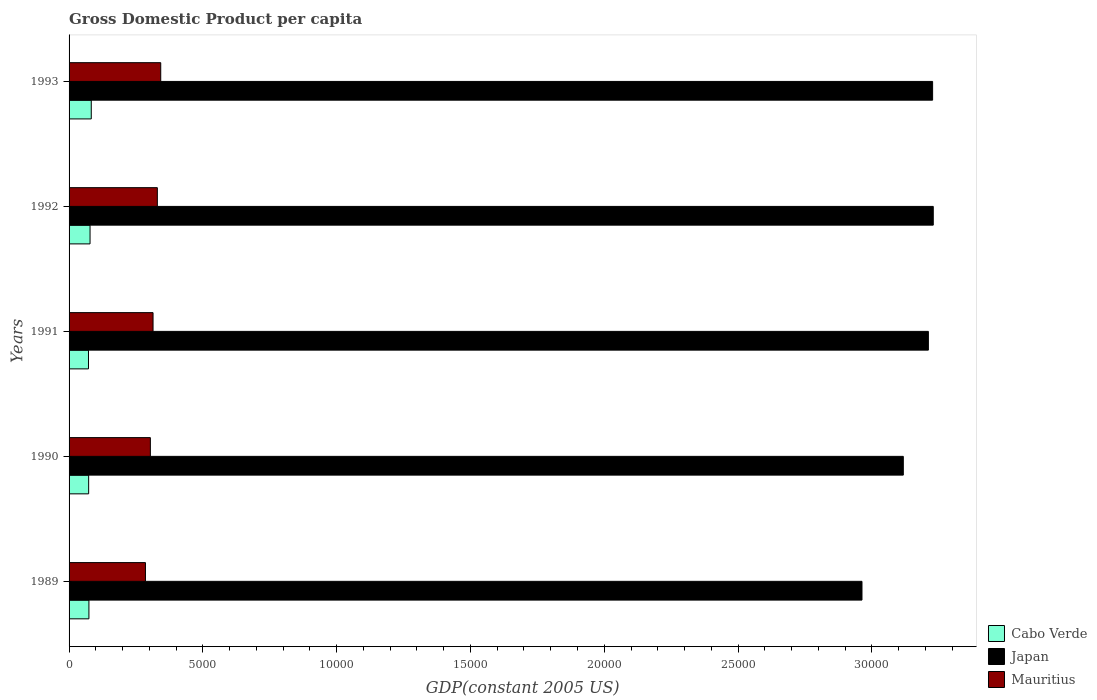How many different coloured bars are there?
Give a very brief answer. 3. How many groups of bars are there?
Offer a terse response. 5. Are the number of bars on each tick of the Y-axis equal?
Provide a succinct answer. Yes. What is the label of the 4th group of bars from the top?
Make the answer very short. 1990. What is the GDP per capita in Cabo Verde in 1990?
Your answer should be compact. 732.17. Across all years, what is the maximum GDP per capita in Japan?
Make the answer very short. 3.23e+04. Across all years, what is the minimum GDP per capita in Japan?
Offer a terse response. 2.96e+04. In which year was the GDP per capita in Cabo Verde maximum?
Provide a succinct answer. 1993. In which year was the GDP per capita in Cabo Verde minimum?
Your answer should be compact. 1991. What is the total GDP per capita in Mauritius in the graph?
Offer a terse response. 1.58e+04. What is the difference between the GDP per capita in Japan in 1989 and that in 1993?
Your answer should be very brief. -2639.3. What is the difference between the GDP per capita in Japan in 1991 and the GDP per capita in Cabo Verde in 1989?
Your answer should be very brief. 3.14e+04. What is the average GDP per capita in Cabo Verde per year?
Your answer should be compact. 762.56. In the year 1993, what is the difference between the GDP per capita in Mauritius and GDP per capita in Japan?
Keep it short and to the point. -2.88e+04. In how many years, is the GDP per capita in Cabo Verde greater than 21000 US$?
Your answer should be very brief. 0. What is the ratio of the GDP per capita in Japan in 1990 to that in 1991?
Give a very brief answer. 0.97. Is the difference between the GDP per capita in Mauritius in 1990 and 1991 greater than the difference between the GDP per capita in Japan in 1990 and 1991?
Provide a short and direct response. Yes. What is the difference between the highest and the second highest GDP per capita in Japan?
Provide a short and direct response. 24.5. What is the difference between the highest and the lowest GDP per capita in Cabo Verde?
Make the answer very short. 104.06. In how many years, is the GDP per capita in Mauritius greater than the average GDP per capita in Mauritius taken over all years?
Ensure brevity in your answer.  2. What does the 1st bar from the top in 1990 represents?
Offer a very short reply. Mauritius. What does the 3rd bar from the bottom in 1990 represents?
Keep it short and to the point. Mauritius. How many bars are there?
Keep it short and to the point. 15. How many years are there in the graph?
Your response must be concise. 5. What is the difference between two consecutive major ticks on the X-axis?
Your answer should be compact. 5000. Does the graph contain any zero values?
Give a very brief answer. No. Where does the legend appear in the graph?
Offer a very short reply. Bottom right. How are the legend labels stacked?
Keep it short and to the point. Vertical. What is the title of the graph?
Your answer should be very brief. Gross Domestic Product per capita. Does "Belgium" appear as one of the legend labels in the graph?
Your answer should be very brief. No. What is the label or title of the X-axis?
Your answer should be very brief. GDP(constant 2005 US). What is the GDP(constant 2005 US) in Cabo Verde in 1989?
Provide a succinct answer. 741.88. What is the GDP(constant 2005 US) of Japan in 1989?
Your answer should be compact. 2.96e+04. What is the GDP(constant 2005 US) of Mauritius in 1989?
Your response must be concise. 2854.06. What is the GDP(constant 2005 US) in Cabo Verde in 1990?
Provide a succinct answer. 732.17. What is the GDP(constant 2005 US) in Japan in 1990?
Your response must be concise. 3.12e+04. What is the GDP(constant 2005 US) of Mauritius in 1990?
Provide a succinct answer. 3037.46. What is the GDP(constant 2005 US) in Cabo Verde in 1991?
Make the answer very short. 725.3. What is the GDP(constant 2005 US) in Japan in 1991?
Provide a succinct answer. 3.21e+04. What is the GDP(constant 2005 US) of Mauritius in 1991?
Keep it short and to the point. 3138.13. What is the GDP(constant 2005 US) of Cabo Verde in 1992?
Offer a terse response. 784.1. What is the GDP(constant 2005 US) in Japan in 1992?
Offer a very short reply. 3.23e+04. What is the GDP(constant 2005 US) of Mauritius in 1992?
Your answer should be compact. 3298.81. What is the GDP(constant 2005 US) in Cabo Verde in 1993?
Keep it short and to the point. 829.36. What is the GDP(constant 2005 US) of Japan in 1993?
Your answer should be very brief. 3.23e+04. What is the GDP(constant 2005 US) in Mauritius in 1993?
Give a very brief answer. 3425.61. Across all years, what is the maximum GDP(constant 2005 US) of Cabo Verde?
Your answer should be compact. 829.36. Across all years, what is the maximum GDP(constant 2005 US) of Japan?
Provide a succinct answer. 3.23e+04. Across all years, what is the maximum GDP(constant 2005 US) of Mauritius?
Your answer should be compact. 3425.61. Across all years, what is the minimum GDP(constant 2005 US) in Cabo Verde?
Provide a succinct answer. 725.3. Across all years, what is the minimum GDP(constant 2005 US) in Japan?
Provide a short and direct response. 2.96e+04. Across all years, what is the minimum GDP(constant 2005 US) in Mauritius?
Provide a succinct answer. 2854.06. What is the total GDP(constant 2005 US) in Cabo Verde in the graph?
Make the answer very short. 3812.82. What is the total GDP(constant 2005 US) of Japan in the graph?
Ensure brevity in your answer.  1.57e+05. What is the total GDP(constant 2005 US) in Mauritius in the graph?
Give a very brief answer. 1.58e+04. What is the difference between the GDP(constant 2005 US) in Cabo Verde in 1989 and that in 1990?
Ensure brevity in your answer.  9.71. What is the difference between the GDP(constant 2005 US) in Japan in 1989 and that in 1990?
Your answer should be very brief. -1544.52. What is the difference between the GDP(constant 2005 US) of Mauritius in 1989 and that in 1990?
Give a very brief answer. -183.4. What is the difference between the GDP(constant 2005 US) of Cabo Verde in 1989 and that in 1991?
Make the answer very short. 16.58. What is the difference between the GDP(constant 2005 US) in Japan in 1989 and that in 1991?
Your answer should be very brief. -2481.07. What is the difference between the GDP(constant 2005 US) of Mauritius in 1989 and that in 1991?
Your answer should be very brief. -284.07. What is the difference between the GDP(constant 2005 US) in Cabo Verde in 1989 and that in 1992?
Your response must be concise. -42.22. What is the difference between the GDP(constant 2005 US) in Japan in 1989 and that in 1992?
Provide a succinct answer. -2663.81. What is the difference between the GDP(constant 2005 US) of Mauritius in 1989 and that in 1992?
Offer a very short reply. -444.75. What is the difference between the GDP(constant 2005 US) in Cabo Verde in 1989 and that in 1993?
Your answer should be very brief. -87.48. What is the difference between the GDP(constant 2005 US) in Japan in 1989 and that in 1993?
Offer a very short reply. -2639.3. What is the difference between the GDP(constant 2005 US) of Mauritius in 1989 and that in 1993?
Your response must be concise. -571.55. What is the difference between the GDP(constant 2005 US) of Cabo Verde in 1990 and that in 1991?
Your answer should be very brief. 6.87. What is the difference between the GDP(constant 2005 US) of Japan in 1990 and that in 1991?
Your response must be concise. -936.55. What is the difference between the GDP(constant 2005 US) of Mauritius in 1990 and that in 1991?
Ensure brevity in your answer.  -100.67. What is the difference between the GDP(constant 2005 US) of Cabo Verde in 1990 and that in 1992?
Provide a succinct answer. -51.93. What is the difference between the GDP(constant 2005 US) of Japan in 1990 and that in 1992?
Provide a short and direct response. -1119.28. What is the difference between the GDP(constant 2005 US) of Mauritius in 1990 and that in 1992?
Your answer should be very brief. -261.35. What is the difference between the GDP(constant 2005 US) in Cabo Verde in 1990 and that in 1993?
Make the answer very short. -97.19. What is the difference between the GDP(constant 2005 US) in Japan in 1990 and that in 1993?
Your response must be concise. -1094.78. What is the difference between the GDP(constant 2005 US) in Mauritius in 1990 and that in 1993?
Your answer should be compact. -388.15. What is the difference between the GDP(constant 2005 US) of Cabo Verde in 1991 and that in 1992?
Ensure brevity in your answer.  -58.8. What is the difference between the GDP(constant 2005 US) in Japan in 1991 and that in 1992?
Offer a very short reply. -182.74. What is the difference between the GDP(constant 2005 US) in Mauritius in 1991 and that in 1992?
Give a very brief answer. -160.69. What is the difference between the GDP(constant 2005 US) in Cabo Verde in 1991 and that in 1993?
Your answer should be very brief. -104.06. What is the difference between the GDP(constant 2005 US) in Japan in 1991 and that in 1993?
Offer a terse response. -158.23. What is the difference between the GDP(constant 2005 US) of Mauritius in 1991 and that in 1993?
Make the answer very short. -287.48. What is the difference between the GDP(constant 2005 US) in Cabo Verde in 1992 and that in 1993?
Your response must be concise. -45.26. What is the difference between the GDP(constant 2005 US) in Japan in 1992 and that in 1993?
Keep it short and to the point. 24.5. What is the difference between the GDP(constant 2005 US) in Mauritius in 1992 and that in 1993?
Keep it short and to the point. -126.79. What is the difference between the GDP(constant 2005 US) in Cabo Verde in 1989 and the GDP(constant 2005 US) in Japan in 1990?
Give a very brief answer. -3.04e+04. What is the difference between the GDP(constant 2005 US) in Cabo Verde in 1989 and the GDP(constant 2005 US) in Mauritius in 1990?
Your answer should be compact. -2295.58. What is the difference between the GDP(constant 2005 US) of Japan in 1989 and the GDP(constant 2005 US) of Mauritius in 1990?
Ensure brevity in your answer.  2.66e+04. What is the difference between the GDP(constant 2005 US) in Cabo Verde in 1989 and the GDP(constant 2005 US) in Japan in 1991?
Offer a very short reply. -3.14e+04. What is the difference between the GDP(constant 2005 US) of Cabo Verde in 1989 and the GDP(constant 2005 US) of Mauritius in 1991?
Provide a short and direct response. -2396.24. What is the difference between the GDP(constant 2005 US) of Japan in 1989 and the GDP(constant 2005 US) of Mauritius in 1991?
Offer a terse response. 2.65e+04. What is the difference between the GDP(constant 2005 US) of Cabo Verde in 1989 and the GDP(constant 2005 US) of Japan in 1992?
Offer a terse response. -3.16e+04. What is the difference between the GDP(constant 2005 US) in Cabo Verde in 1989 and the GDP(constant 2005 US) in Mauritius in 1992?
Provide a succinct answer. -2556.93. What is the difference between the GDP(constant 2005 US) of Japan in 1989 and the GDP(constant 2005 US) of Mauritius in 1992?
Your answer should be very brief. 2.63e+04. What is the difference between the GDP(constant 2005 US) in Cabo Verde in 1989 and the GDP(constant 2005 US) in Japan in 1993?
Ensure brevity in your answer.  -3.15e+04. What is the difference between the GDP(constant 2005 US) of Cabo Verde in 1989 and the GDP(constant 2005 US) of Mauritius in 1993?
Provide a short and direct response. -2683.72. What is the difference between the GDP(constant 2005 US) in Japan in 1989 and the GDP(constant 2005 US) in Mauritius in 1993?
Offer a terse response. 2.62e+04. What is the difference between the GDP(constant 2005 US) in Cabo Verde in 1990 and the GDP(constant 2005 US) in Japan in 1991?
Provide a succinct answer. -3.14e+04. What is the difference between the GDP(constant 2005 US) in Cabo Verde in 1990 and the GDP(constant 2005 US) in Mauritius in 1991?
Give a very brief answer. -2405.96. What is the difference between the GDP(constant 2005 US) of Japan in 1990 and the GDP(constant 2005 US) of Mauritius in 1991?
Offer a terse response. 2.80e+04. What is the difference between the GDP(constant 2005 US) of Cabo Verde in 1990 and the GDP(constant 2005 US) of Japan in 1992?
Make the answer very short. -3.16e+04. What is the difference between the GDP(constant 2005 US) in Cabo Verde in 1990 and the GDP(constant 2005 US) in Mauritius in 1992?
Ensure brevity in your answer.  -2566.64. What is the difference between the GDP(constant 2005 US) in Japan in 1990 and the GDP(constant 2005 US) in Mauritius in 1992?
Offer a terse response. 2.79e+04. What is the difference between the GDP(constant 2005 US) in Cabo Verde in 1990 and the GDP(constant 2005 US) in Japan in 1993?
Your answer should be compact. -3.15e+04. What is the difference between the GDP(constant 2005 US) in Cabo Verde in 1990 and the GDP(constant 2005 US) in Mauritius in 1993?
Your answer should be very brief. -2693.44. What is the difference between the GDP(constant 2005 US) in Japan in 1990 and the GDP(constant 2005 US) in Mauritius in 1993?
Make the answer very short. 2.77e+04. What is the difference between the GDP(constant 2005 US) in Cabo Verde in 1991 and the GDP(constant 2005 US) in Japan in 1992?
Your answer should be compact. -3.16e+04. What is the difference between the GDP(constant 2005 US) of Cabo Verde in 1991 and the GDP(constant 2005 US) of Mauritius in 1992?
Make the answer very short. -2573.51. What is the difference between the GDP(constant 2005 US) in Japan in 1991 and the GDP(constant 2005 US) in Mauritius in 1992?
Make the answer very short. 2.88e+04. What is the difference between the GDP(constant 2005 US) of Cabo Verde in 1991 and the GDP(constant 2005 US) of Japan in 1993?
Provide a short and direct response. -3.15e+04. What is the difference between the GDP(constant 2005 US) of Cabo Verde in 1991 and the GDP(constant 2005 US) of Mauritius in 1993?
Your response must be concise. -2700.31. What is the difference between the GDP(constant 2005 US) in Japan in 1991 and the GDP(constant 2005 US) in Mauritius in 1993?
Provide a short and direct response. 2.87e+04. What is the difference between the GDP(constant 2005 US) in Cabo Verde in 1992 and the GDP(constant 2005 US) in Japan in 1993?
Give a very brief answer. -3.15e+04. What is the difference between the GDP(constant 2005 US) in Cabo Verde in 1992 and the GDP(constant 2005 US) in Mauritius in 1993?
Offer a terse response. -2641.51. What is the difference between the GDP(constant 2005 US) of Japan in 1992 and the GDP(constant 2005 US) of Mauritius in 1993?
Provide a short and direct response. 2.89e+04. What is the average GDP(constant 2005 US) of Cabo Verde per year?
Give a very brief answer. 762.56. What is the average GDP(constant 2005 US) of Japan per year?
Your answer should be compact. 3.15e+04. What is the average GDP(constant 2005 US) of Mauritius per year?
Your response must be concise. 3150.81. In the year 1989, what is the difference between the GDP(constant 2005 US) of Cabo Verde and GDP(constant 2005 US) of Japan?
Ensure brevity in your answer.  -2.89e+04. In the year 1989, what is the difference between the GDP(constant 2005 US) in Cabo Verde and GDP(constant 2005 US) in Mauritius?
Your answer should be very brief. -2112.18. In the year 1989, what is the difference between the GDP(constant 2005 US) in Japan and GDP(constant 2005 US) in Mauritius?
Keep it short and to the point. 2.68e+04. In the year 1990, what is the difference between the GDP(constant 2005 US) of Cabo Verde and GDP(constant 2005 US) of Japan?
Give a very brief answer. -3.04e+04. In the year 1990, what is the difference between the GDP(constant 2005 US) of Cabo Verde and GDP(constant 2005 US) of Mauritius?
Offer a very short reply. -2305.29. In the year 1990, what is the difference between the GDP(constant 2005 US) in Japan and GDP(constant 2005 US) in Mauritius?
Make the answer very short. 2.81e+04. In the year 1991, what is the difference between the GDP(constant 2005 US) in Cabo Verde and GDP(constant 2005 US) in Japan?
Provide a short and direct response. -3.14e+04. In the year 1991, what is the difference between the GDP(constant 2005 US) in Cabo Verde and GDP(constant 2005 US) in Mauritius?
Give a very brief answer. -2412.83. In the year 1991, what is the difference between the GDP(constant 2005 US) in Japan and GDP(constant 2005 US) in Mauritius?
Ensure brevity in your answer.  2.90e+04. In the year 1992, what is the difference between the GDP(constant 2005 US) of Cabo Verde and GDP(constant 2005 US) of Japan?
Offer a terse response. -3.15e+04. In the year 1992, what is the difference between the GDP(constant 2005 US) of Cabo Verde and GDP(constant 2005 US) of Mauritius?
Your answer should be compact. -2514.71. In the year 1992, what is the difference between the GDP(constant 2005 US) of Japan and GDP(constant 2005 US) of Mauritius?
Offer a very short reply. 2.90e+04. In the year 1993, what is the difference between the GDP(constant 2005 US) in Cabo Verde and GDP(constant 2005 US) in Japan?
Offer a terse response. -3.14e+04. In the year 1993, what is the difference between the GDP(constant 2005 US) of Cabo Verde and GDP(constant 2005 US) of Mauritius?
Keep it short and to the point. -2596.25. In the year 1993, what is the difference between the GDP(constant 2005 US) of Japan and GDP(constant 2005 US) of Mauritius?
Offer a very short reply. 2.88e+04. What is the ratio of the GDP(constant 2005 US) of Cabo Verde in 1989 to that in 1990?
Ensure brevity in your answer.  1.01. What is the ratio of the GDP(constant 2005 US) of Japan in 1989 to that in 1990?
Your answer should be compact. 0.95. What is the ratio of the GDP(constant 2005 US) in Mauritius in 1989 to that in 1990?
Make the answer very short. 0.94. What is the ratio of the GDP(constant 2005 US) in Cabo Verde in 1989 to that in 1991?
Provide a succinct answer. 1.02. What is the ratio of the GDP(constant 2005 US) of Japan in 1989 to that in 1991?
Offer a terse response. 0.92. What is the ratio of the GDP(constant 2005 US) of Mauritius in 1989 to that in 1991?
Provide a succinct answer. 0.91. What is the ratio of the GDP(constant 2005 US) in Cabo Verde in 1989 to that in 1992?
Your response must be concise. 0.95. What is the ratio of the GDP(constant 2005 US) of Japan in 1989 to that in 1992?
Offer a very short reply. 0.92. What is the ratio of the GDP(constant 2005 US) of Mauritius in 1989 to that in 1992?
Your answer should be compact. 0.87. What is the ratio of the GDP(constant 2005 US) in Cabo Verde in 1989 to that in 1993?
Offer a terse response. 0.89. What is the ratio of the GDP(constant 2005 US) of Japan in 1989 to that in 1993?
Offer a terse response. 0.92. What is the ratio of the GDP(constant 2005 US) of Mauritius in 1989 to that in 1993?
Your response must be concise. 0.83. What is the ratio of the GDP(constant 2005 US) in Cabo Verde in 1990 to that in 1991?
Give a very brief answer. 1.01. What is the ratio of the GDP(constant 2005 US) of Japan in 1990 to that in 1991?
Your answer should be compact. 0.97. What is the ratio of the GDP(constant 2005 US) in Mauritius in 1990 to that in 1991?
Give a very brief answer. 0.97. What is the ratio of the GDP(constant 2005 US) of Cabo Verde in 1990 to that in 1992?
Offer a terse response. 0.93. What is the ratio of the GDP(constant 2005 US) in Japan in 1990 to that in 1992?
Keep it short and to the point. 0.97. What is the ratio of the GDP(constant 2005 US) in Mauritius in 1990 to that in 1992?
Offer a very short reply. 0.92. What is the ratio of the GDP(constant 2005 US) in Cabo Verde in 1990 to that in 1993?
Your response must be concise. 0.88. What is the ratio of the GDP(constant 2005 US) of Japan in 1990 to that in 1993?
Your answer should be very brief. 0.97. What is the ratio of the GDP(constant 2005 US) in Mauritius in 1990 to that in 1993?
Your answer should be compact. 0.89. What is the ratio of the GDP(constant 2005 US) of Cabo Verde in 1991 to that in 1992?
Offer a terse response. 0.93. What is the ratio of the GDP(constant 2005 US) in Mauritius in 1991 to that in 1992?
Provide a short and direct response. 0.95. What is the ratio of the GDP(constant 2005 US) of Cabo Verde in 1991 to that in 1993?
Your answer should be very brief. 0.87. What is the ratio of the GDP(constant 2005 US) in Mauritius in 1991 to that in 1993?
Give a very brief answer. 0.92. What is the ratio of the GDP(constant 2005 US) of Cabo Verde in 1992 to that in 1993?
Offer a very short reply. 0.95. What is the ratio of the GDP(constant 2005 US) of Japan in 1992 to that in 1993?
Give a very brief answer. 1. What is the ratio of the GDP(constant 2005 US) of Mauritius in 1992 to that in 1993?
Make the answer very short. 0.96. What is the difference between the highest and the second highest GDP(constant 2005 US) in Cabo Verde?
Your response must be concise. 45.26. What is the difference between the highest and the second highest GDP(constant 2005 US) in Japan?
Ensure brevity in your answer.  24.5. What is the difference between the highest and the second highest GDP(constant 2005 US) of Mauritius?
Your response must be concise. 126.79. What is the difference between the highest and the lowest GDP(constant 2005 US) of Cabo Verde?
Offer a terse response. 104.06. What is the difference between the highest and the lowest GDP(constant 2005 US) of Japan?
Your answer should be very brief. 2663.81. What is the difference between the highest and the lowest GDP(constant 2005 US) of Mauritius?
Your answer should be very brief. 571.55. 